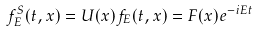Convert formula to latex. <formula><loc_0><loc_0><loc_500><loc_500>f ^ { S } _ { E } ( t , { x } ) = U ( x ) f _ { E } ( t , { x } ) = F ( { x } ) e ^ { - i E t }</formula> 